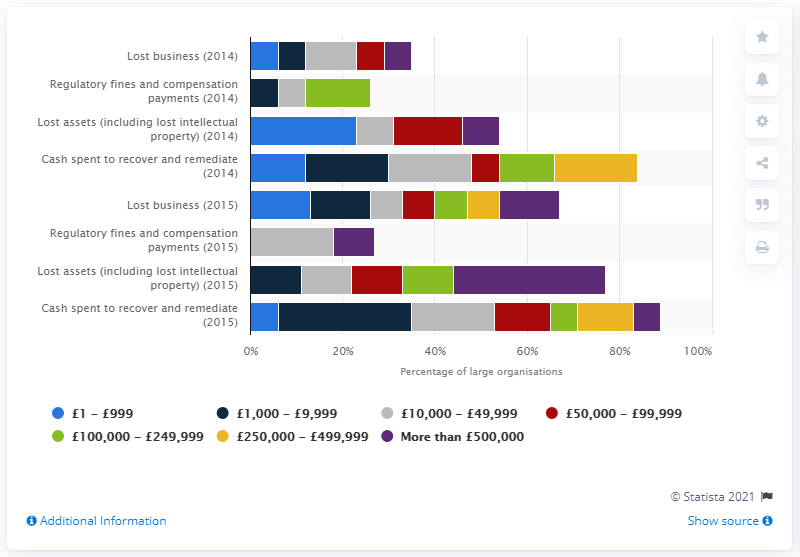Identify some key points in this picture. Eight percent of organizations reported losses of more than 500,000 British pounds in 2014. 